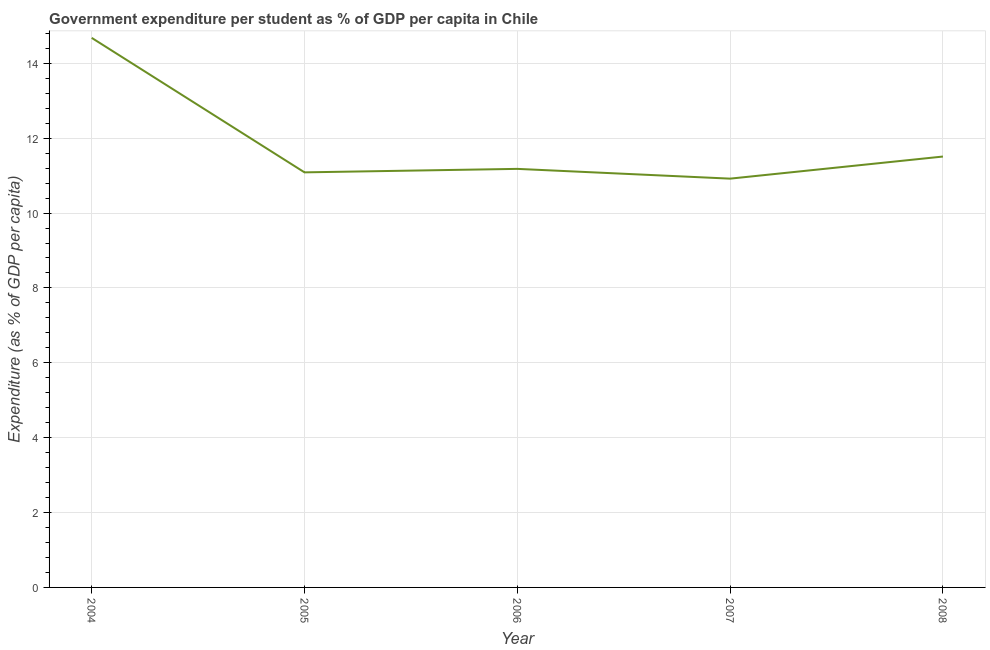What is the government expenditure per student in 2005?
Keep it short and to the point. 11.09. Across all years, what is the maximum government expenditure per student?
Offer a terse response. 14.68. Across all years, what is the minimum government expenditure per student?
Provide a succinct answer. 10.92. What is the sum of the government expenditure per student?
Offer a very short reply. 59.38. What is the difference between the government expenditure per student in 2007 and 2008?
Make the answer very short. -0.59. What is the average government expenditure per student per year?
Provide a short and direct response. 11.88. What is the median government expenditure per student?
Provide a short and direct response. 11.18. In how many years, is the government expenditure per student greater than 10.8 %?
Keep it short and to the point. 5. Do a majority of the years between 2006 and 2008 (inclusive) have government expenditure per student greater than 11.6 %?
Give a very brief answer. No. What is the ratio of the government expenditure per student in 2004 to that in 2008?
Give a very brief answer. 1.28. Is the government expenditure per student in 2005 less than that in 2006?
Make the answer very short. Yes. What is the difference between the highest and the second highest government expenditure per student?
Keep it short and to the point. 3.17. Is the sum of the government expenditure per student in 2006 and 2007 greater than the maximum government expenditure per student across all years?
Give a very brief answer. Yes. What is the difference between the highest and the lowest government expenditure per student?
Make the answer very short. 3.76. Does the government expenditure per student monotonically increase over the years?
Make the answer very short. No. What is the title of the graph?
Offer a very short reply. Government expenditure per student as % of GDP per capita in Chile. What is the label or title of the X-axis?
Keep it short and to the point. Year. What is the label or title of the Y-axis?
Your answer should be very brief. Expenditure (as % of GDP per capita). What is the Expenditure (as % of GDP per capita) in 2004?
Your answer should be very brief. 14.68. What is the Expenditure (as % of GDP per capita) of 2005?
Your answer should be compact. 11.09. What is the Expenditure (as % of GDP per capita) in 2006?
Make the answer very short. 11.18. What is the Expenditure (as % of GDP per capita) in 2007?
Ensure brevity in your answer.  10.92. What is the Expenditure (as % of GDP per capita) in 2008?
Ensure brevity in your answer.  11.51. What is the difference between the Expenditure (as % of GDP per capita) in 2004 and 2005?
Your response must be concise. 3.59. What is the difference between the Expenditure (as % of GDP per capita) in 2004 and 2006?
Offer a very short reply. 3.5. What is the difference between the Expenditure (as % of GDP per capita) in 2004 and 2007?
Provide a short and direct response. 3.76. What is the difference between the Expenditure (as % of GDP per capita) in 2004 and 2008?
Your answer should be compact. 3.17. What is the difference between the Expenditure (as % of GDP per capita) in 2005 and 2006?
Your response must be concise. -0.09. What is the difference between the Expenditure (as % of GDP per capita) in 2005 and 2007?
Provide a short and direct response. 0.17. What is the difference between the Expenditure (as % of GDP per capita) in 2005 and 2008?
Offer a terse response. -0.42. What is the difference between the Expenditure (as % of GDP per capita) in 2006 and 2007?
Provide a succinct answer. 0.26. What is the difference between the Expenditure (as % of GDP per capita) in 2006 and 2008?
Ensure brevity in your answer.  -0.33. What is the difference between the Expenditure (as % of GDP per capita) in 2007 and 2008?
Make the answer very short. -0.59. What is the ratio of the Expenditure (as % of GDP per capita) in 2004 to that in 2005?
Make the answer very short. 1.32. What is the ratio of the Expenditure (as % of GDP per capita) in 2004 to that in 2006?
Keep it short and to the point. 1.31. What is the ratio of the Expenditure (as % of GDP per capita) in 2004 to that in 2007?
Your answer should be compact. 1.34. What is the ratio of the Expenditure (as % of GDP per capita) in 2004 to that in 2008?
Provide a short and direct response. 1.27. What is the ratio of the Expenditure (as % of GDP per capita) in 2005 to that in 2006?
Ensure brevity in your answer.  0.99. What is the ratio of the Expenditure (as % of GDP per capita) in 2005 to that in 2007?
Offer a terse response. 1.01. What is the ratio of the Expenditure (as % of GDP per capita) in 2006 to that in 2008?
Keep it short and to the point. 0.97. What is the ratio of the Expenditure (as % of GDP per capita) in 2007 to that in 2008?
Give a very brief answer. 0.95. 